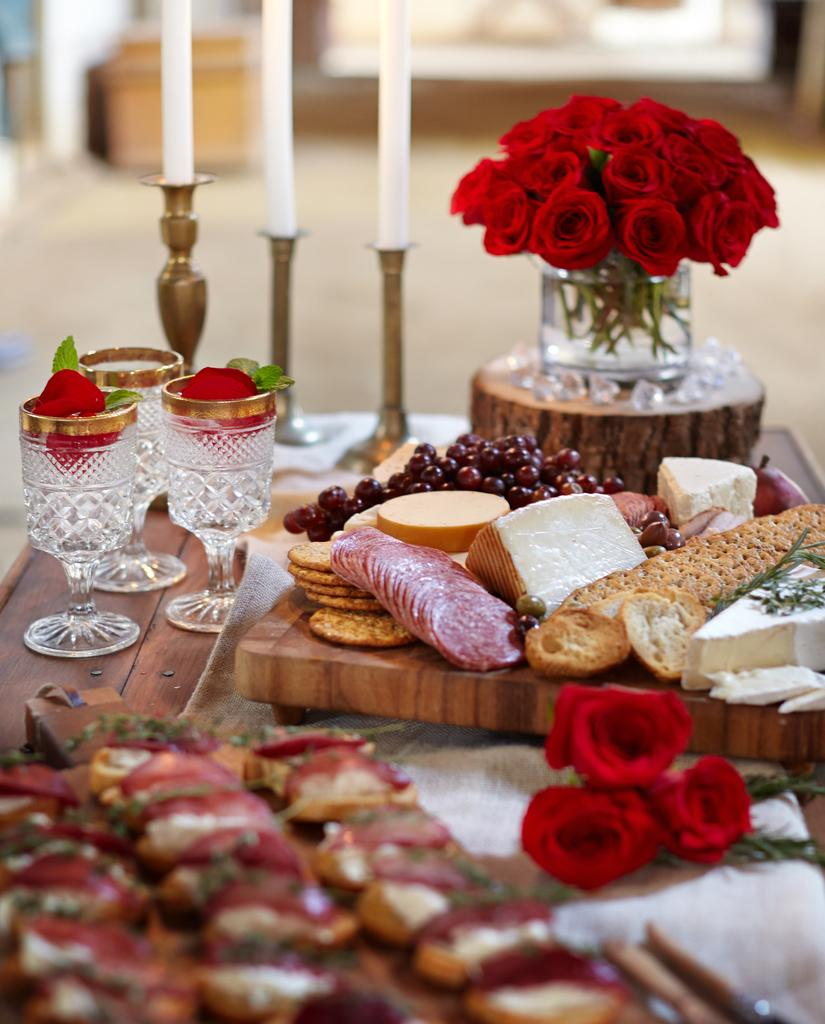What types of items can be seen in the image? There are various types of food, glasses, candles, and roses in the image. What might be used for drinking in the image? The glasses in the image might be used for drinking. What is used for illumination in the image? Candles are visible in the image for illumination. What type of flower is present in the image? Roses are present in the image. What type of steel material is used to make the camp in the image? There is no camp or steel material present in the image. How many stockings are hanging from the roses in the image? There are no stockings present in the image; only roses are visible. 